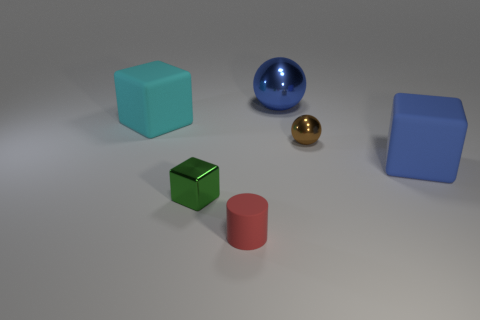Is there anything else that is the same shape as the small rubber object?
Keep it short and to the point. No. What is the shape of the object that is both on the left side of the blue rubber cube and on the right side of the blue metal object?
Keep it short and to the point. Sphere. There is a object behind the large cyan object; what is its color?
Ensure brevity in your answer.  Blue. There is a metal thing that is in front of the big ball and left of the brown shiny ball; what is its size?
Make the answer very short. Small. Do the cyan block and the sphere that is on the right side of the big blue metal ball have the same material?
Your answer should be compact. No. How many large blue objects have the same shape as the small brown thing?
Your answer should be compact. 1. What material is the other big thing that is the same color as the large shiny thing?
Offer a terse response. Rubber. What number of large yellow rubber blocks are there?
Provide a succinct answer. 0. Do the red rubber thing and the thing behind the big cyan cube have the same shape?
Your response must be concise. No. What number of objects are rubber blocks or big rubber blocks that are behind the green object?
Give a very brief answer. 2. 